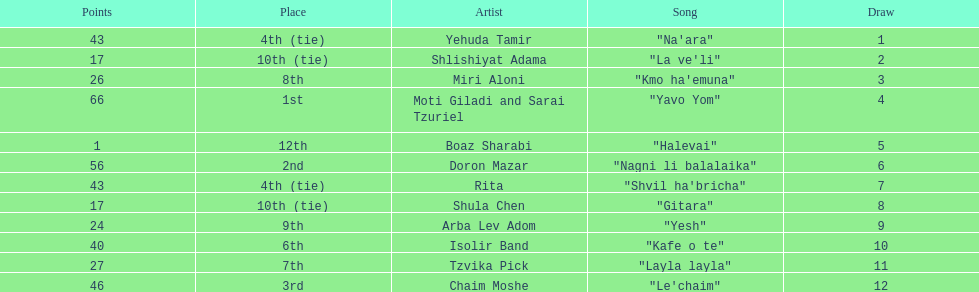What song is listed in the table right before layla layla? "Kafe o te". 